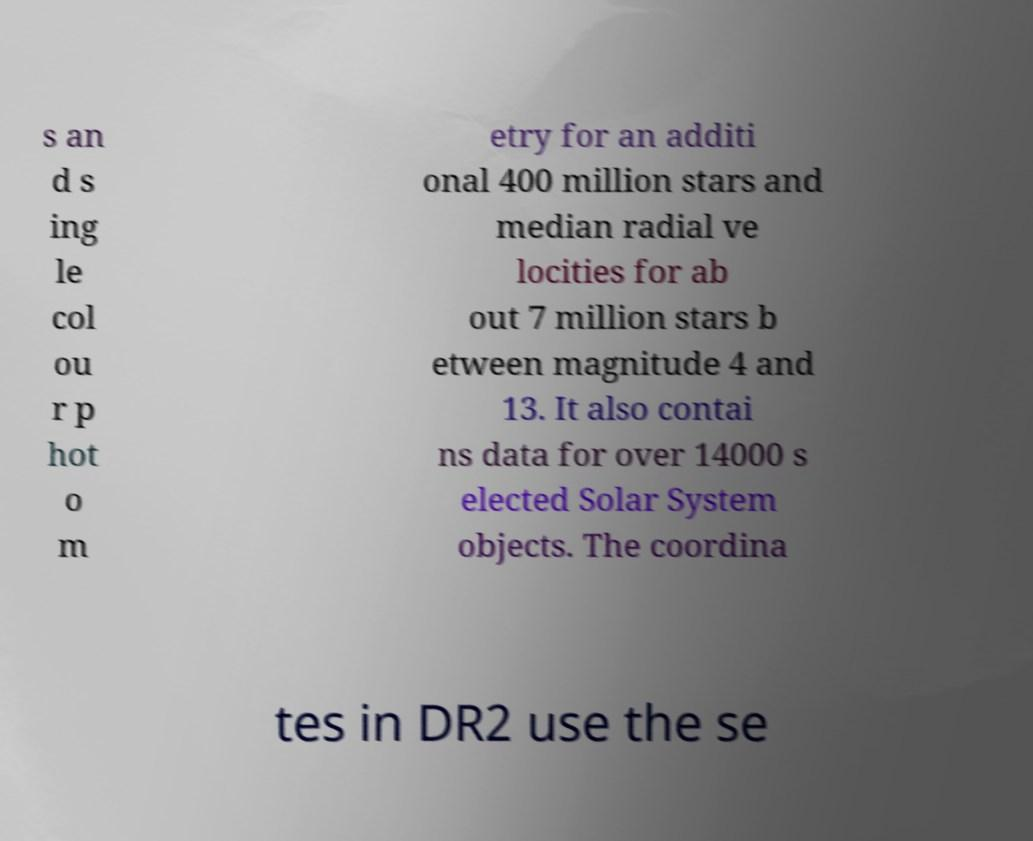There's text embedded in this image that I need extracted. Can you transcribe it verbatim? s an d s ing le col ou r p hot o m etry for an additi onal 400 million stars and median radial ve locities for ab out 7 million stars b etween magnitude 4 and 13. It also contai ns data for over 14000 s elected Solar System objects. The coordina tes in DR2 use the se 